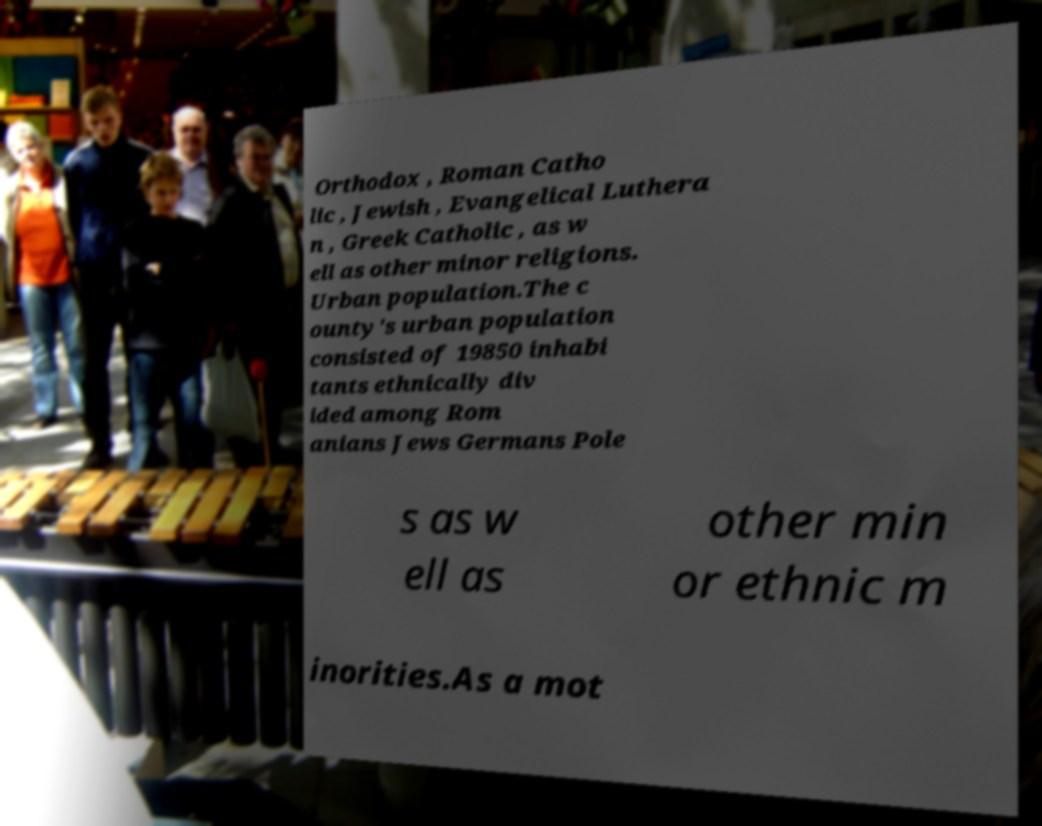What messages or text are displayed in this image? I need them in a readable, typed format. Orthodox , Roman Catho lic , Jewish , Evangelical Luthera n , Greek Catholic , as w ell as other minor religions. Urban population.The c ounty's urban population consisted of 19850 inhabi tants ethnically div ided among Rom anians Jews Germans Pole s as w ell as other min or ethnic m inorities.As a mot 